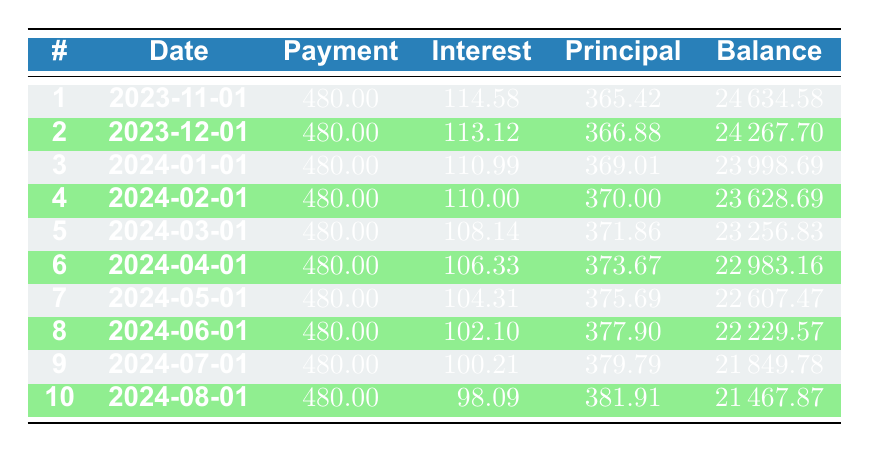What is the total amount of the loan? The total loan amount is stated directly at the beginning of the table, and it shows 25,000.
Answer: 25000 How much is the monthly payment? The monthly payment is listed as 480.00 in the payment schedule, which is the same for each month in the loan term.
Answer: 480.00 What is the interest payment for the first month? The interest payment for the first month is clearly shown in the table, listed as 114.58.
Answer: 114.58 What is the remaining balance after the third payment? To find the remaining balance after the third payment, look at the row for payment number 3, which shows a remaining balance of 23998.69.
Answer: 23998.69 Is the principal payment for the second month greater than that of the first month? The principal payment for the second month is 366.88 and for the first month, it is 365.42. Since 366.88 is greater than 365.42, the statement is true.
Answer: Yes What is the total interest paid after the first three payments? The interest payments for the first three months are 114.58, 113.12, and 110.99. Adding these gives 114.58 + 113.12 + 110.99 = 338.69.
Answer: 338.69 What is the average principal payment over the first ten payments? The principal payments consist of 365.42, 366.88, 369.01, 370.00, 371.86, 373.67, 375.69, 377.90, 379.79, and 381.91. To find the average, sum these values and divide by 10. The total is 3700.32, so the average is 3700.32 / 10 = 370.03.
Answer: 370.03 How does the interest payment change from the first month to the last month shown in the table? The interest payment drops from 114.58 in the first month to 98.09 in the last month (payment number 10). This indicates a decrease of 16.49.
Answer: Decreasing by 16.49 What is the percentage of each monthly payment that goes towards principal in the first month? In the first month, the payment is 480.00 and the principal payment is 365.42. To find the percentage, calculate (365.42 / 480.00) * 100, which equals approximately 76.13%.
Answer: 76.13% 